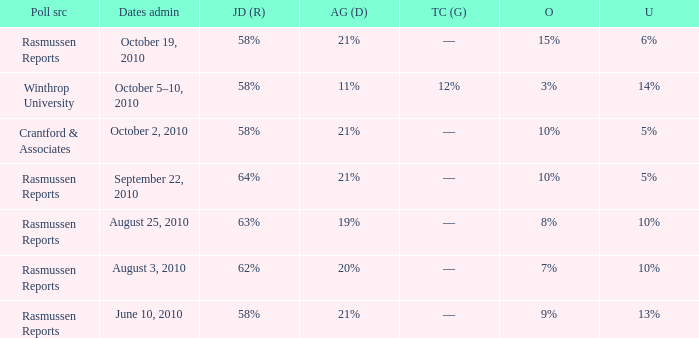Can you give me this table as a dict? {'header': ['Poll src', 'Dates admin', 'JD (R)', 'AG (D)', 'TC (G)', 'O', 'U'], 'rows': [['Rasmussen Reports', 'October 19, 2010', '58%', '21%', '––', '15%', '6%'], ['Winthrop University', 'October 5–10, 2010', '58%', '11%', '12%', '3%', '14%'], ['Crantford & Associates', 'October 2, 2010', '58%', '21%', '––', '10%', '5%'], ['Rasmussen Reports', 'September 22, 2010', '64%', '21%', '––', '10%', '5%'], ['Rasmussen Reports', 'August 25, 2010', '63%', '19%', '––', '8%', '10%'], ['Rasmussen Reports', 'August 3, 2010', '62%', '20%', '––', '7%', '10%'], ['Rasmussen Reports', 'June 10, 2010', '58%', '21%', '––', '9%', '13%']]} Which poll source determined undecided of 5% and Jim DeMint (R) of 58%? Crantford & Associates. 